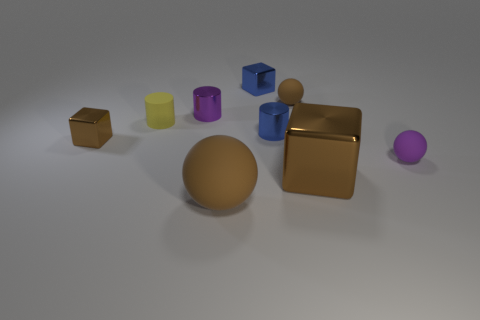Are there any small spheres made of the same material as the small brown block?
Provide a succinct answer. No. What is the size of the matte sphere on the left side of the brown matte thing behind the tiny purple rubber sphere?
Your response must be concise. Large. Is the number of yellow matte things greater than the number of small cubes?
Your response must be concise. No. There is a brown metal object on the left side of the blue cylinder; is it the same size as the blue cylinder?
Provide a succinct answer. Yes. What number of large matte cubes have the same color as the large metallic block?
Give a very brief answer. 0. Do the yellow matte thing and the large rubber thing have the same shape?
Offer a very short reply. No. There is another brown matte thing that is the same shape as the tiny brown matte object; what size is it?
Provide a short and direct response. Large. Is the number of spheres on the right side of the tiny brown metal block greater than the number of rubber spheres that are in front of the small purple cylinder?
Make the answer very short. Yes. Is the material of the blue cylinder the same as the big ball to the left of the tiny brown matte sphere?
Ensure brevity in your answer.  No. What is the color of the object that is right of the small blue shiny cylinder and behind the tiny purple shiny object?
Offer a very short reply. Brown. 